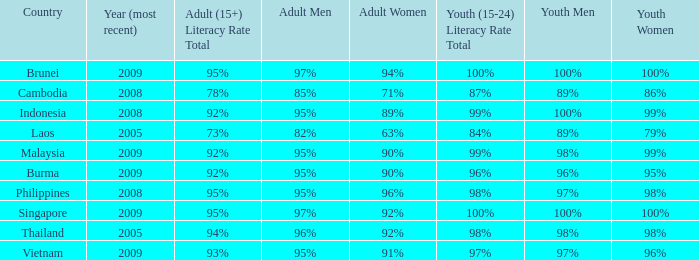What country has a Youth (15-24) Literacy Rate Total of 99%, and a Youth Men of 98%? Malaysia. 